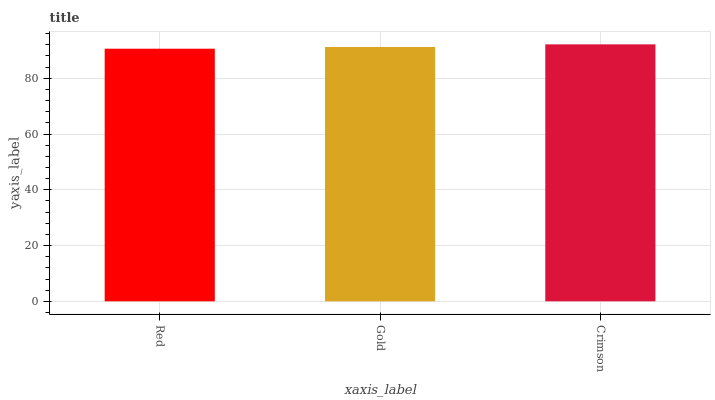Is Red the minimum?
Answer yes or no. Yes. Is Crimson the maximum?
Answer yes or no. Yes. Is Gold the minimum?
Answer yes or no. No. Is Gold the maximum?
Answer yes or no. No. Is Gold greater than Red?
Answer yes or no. Yes. Is Red less than Gold?
Answer yes or no. Yes. Is Red greater than Gold?
Answer yes or no. No. Is Gold less than Red?
Answer yes or no. No. Is Gold the high median?
Answer yes or no. Yes. Is Gold the low median?
Answer yes or no. Yes. Is Crimson the high median?
Answer yes or no. No. Is Red the low median?
Answer yes or no. No. 